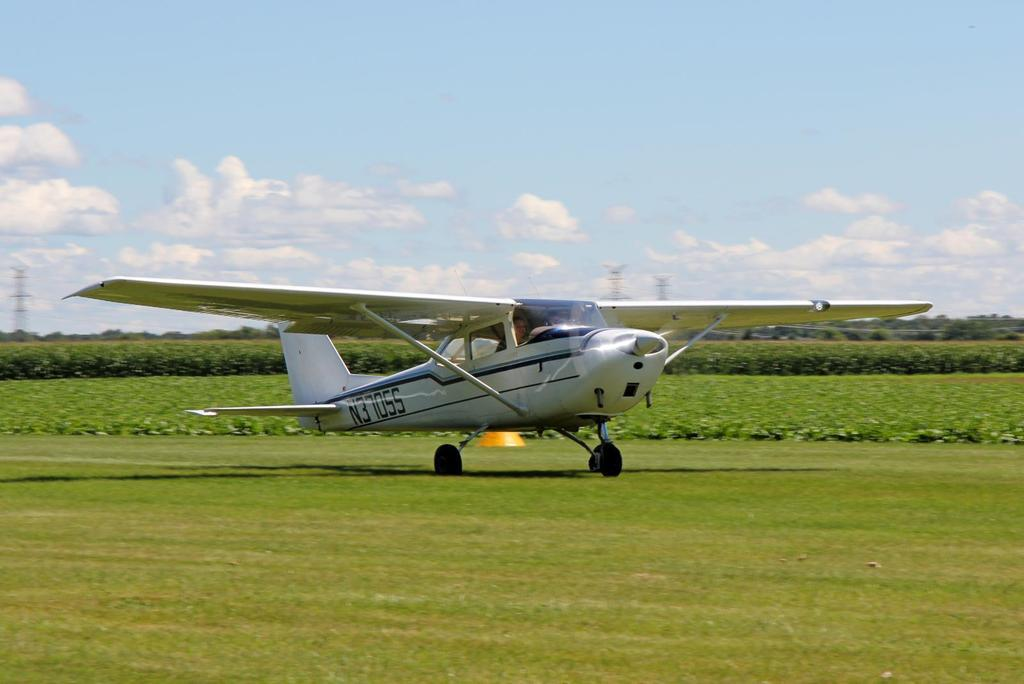What is the main subject of the image? There is an aeroplane in the center of the image. What can be seen in the background of the image? There are bushes, trees, towers, and the sky visible in the background of the image. What type of soup is being served in the image? There is no soup present in the image; it features an aeroplane and various elements in the background. 